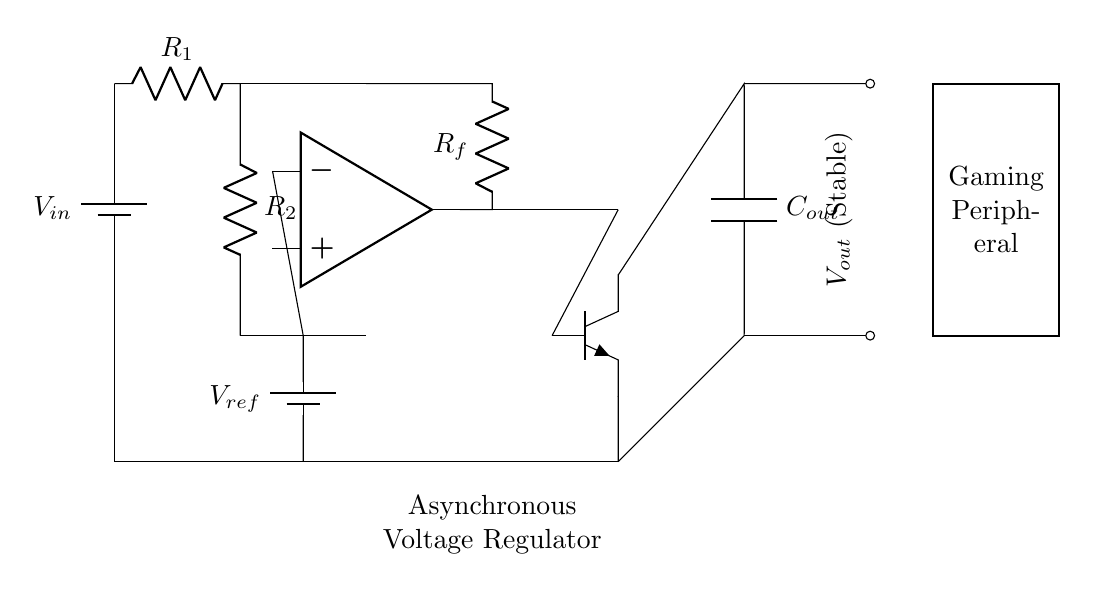What is the input voltage symbol in this circuit? The input voltage is represented by the battery symbol labeled as Vin. This indicates the source that provides power to the circuit.
Answer: Vin What type of amplifier is used in this circuit? The circuit includes an operational amplifier (indicated by "op amp"), which is utilized for the error amplification in the feedback loop.
Answer: Operational amplifier What does Rf represent in this circuit? Rf is the feedback resistor, which is responsible for providing feedback from the output stage to the error amplifier to maintain voltage stability.
Answer: Feedback resistor What is the purpose of the voltage divider in this circuit? The voltage divider formed by R1 and R2 is used to scale down the input voltage to the error amplifier, creating a reference point for comparison with the reference voltage.
Answer: Scale down voltage What type of output transistor is used in this circuit? The circuit employs an NPN transistor (indicated by "npn"), which functions as the output stage to regulate the current based on the feedback from the operational amplifier.
Answer: NPN transistor What is the output component of this circuit? The component that stabilizes the output voltage is represented by the capacitor labeled as Cout, which helps to filter and smooth the voltage supplied to the gaming peripheral.
Answer: Capacitor What do the labels indicate for Vout? The label indicates that Vout is the stable output voltage provided by the regulator, which ensures that the voltage remains constant under varying load conditions.
Answer: Stable output voltage 